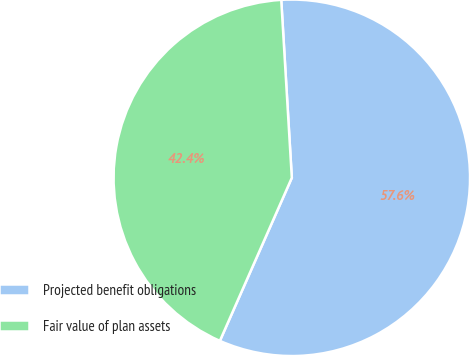Convert chart to OTSL. <chart><loc_0><loc_0><loc_500><loc_500><pie_chart><fcel>Projected benefit obligations<fcel>Fair value of plan assets<nl><fcel>57.56%<fcel>42.44%<nl></chart> 